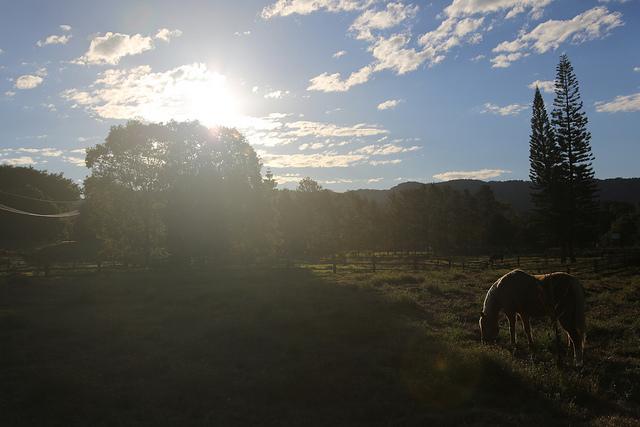Are the animals hindering traffic?
Be succinct. No. Is the sun setting?
Concise answer only. Yes. Is the patch of light illuminating the animals from the photographer's perspective?
Answer briefly. Yes. Is the sun rising or setting?
Write a very short answer. Rising. What type of weather is featured in the picture?
Give a very brief answer. Sunny. Is the horse wearing a saddle?
Short answer required. No. Is it morning?
Short answer required. Yes. 